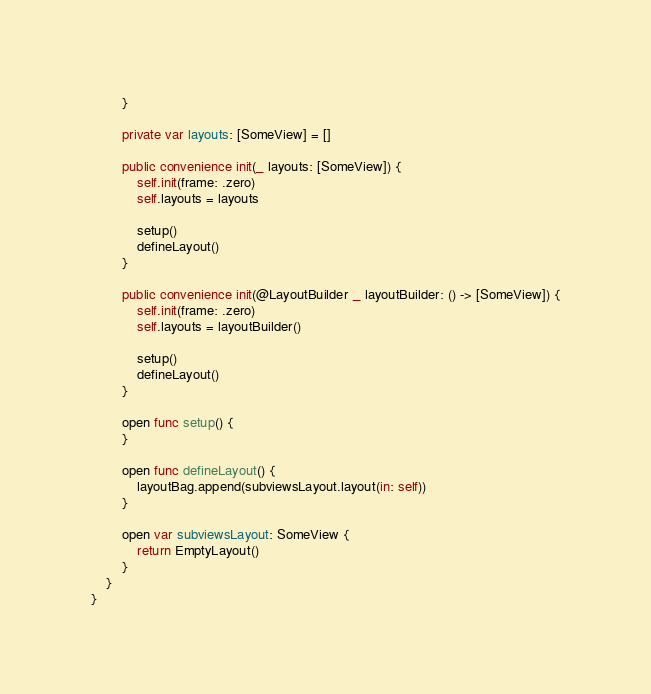Convert code to text. <code><loc_0><loc_0><loc_500><loc_500><_Swift_>        }
        
        private var layouts: [SomeView] = []
        
        public convenience init(_ layouts: [SomeView]) {
            self.init(frame: .zero)
            self.layouts = layouts
            
            setup()
            defineLayout()
        }
        
        public convenience init(@LayoutBuilder _ layoutBuilder: () -> [SomeView]) {
            self.init(frame: .zero)
            self.layouts = layoutBuilder()
            
            setup()
            defineLayout()
        }
        
        open func setup() {
        }
        
        open func defineLayout() {
            layoutBag.append(subviewsLayout.layout(in: self))
        }
        
        open var subviewsLayout: SomeView {
            return EmptyLayout()
        }
    }
}

</code> 